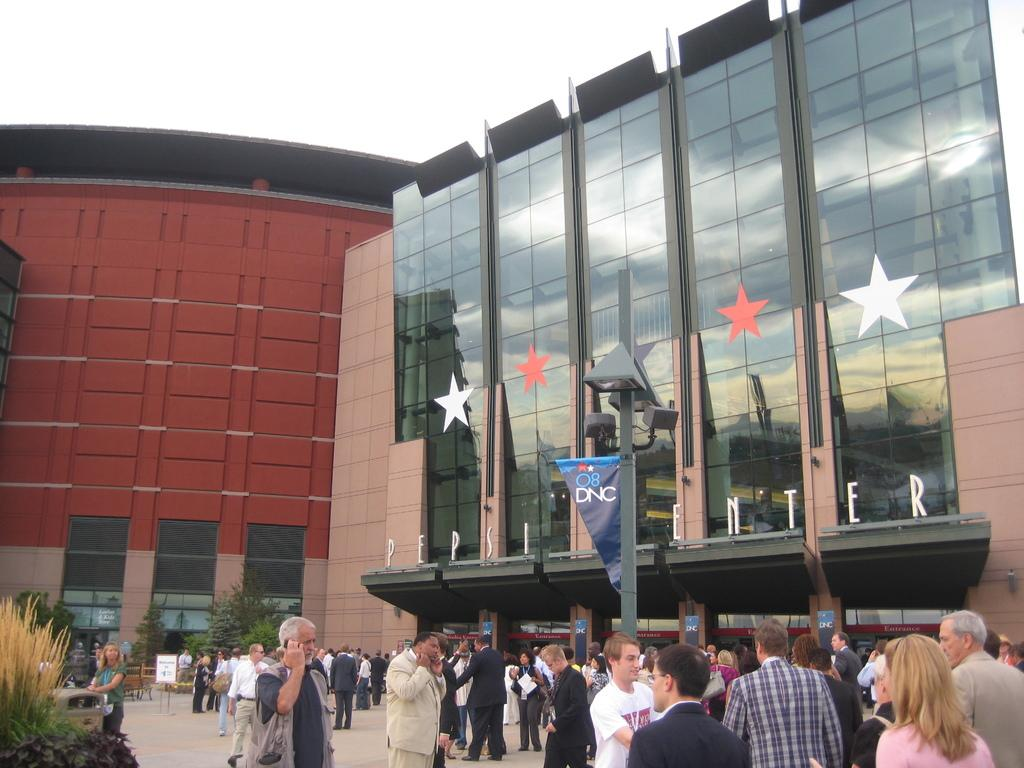What are the people in the image doing? The people in the image are walking on a pavement. What can be seen in the background of the image? There is a building in the background, and there are trees near the building. Are there any plants visible in the image? Yes, there are plants on the bottom left of the image. What grade did the writer receive for their work in the image? There is no writer or work present in the image, so it is not possible to determine a grade. Can you see any chickens in the image? There are no chickens visible in the image. 